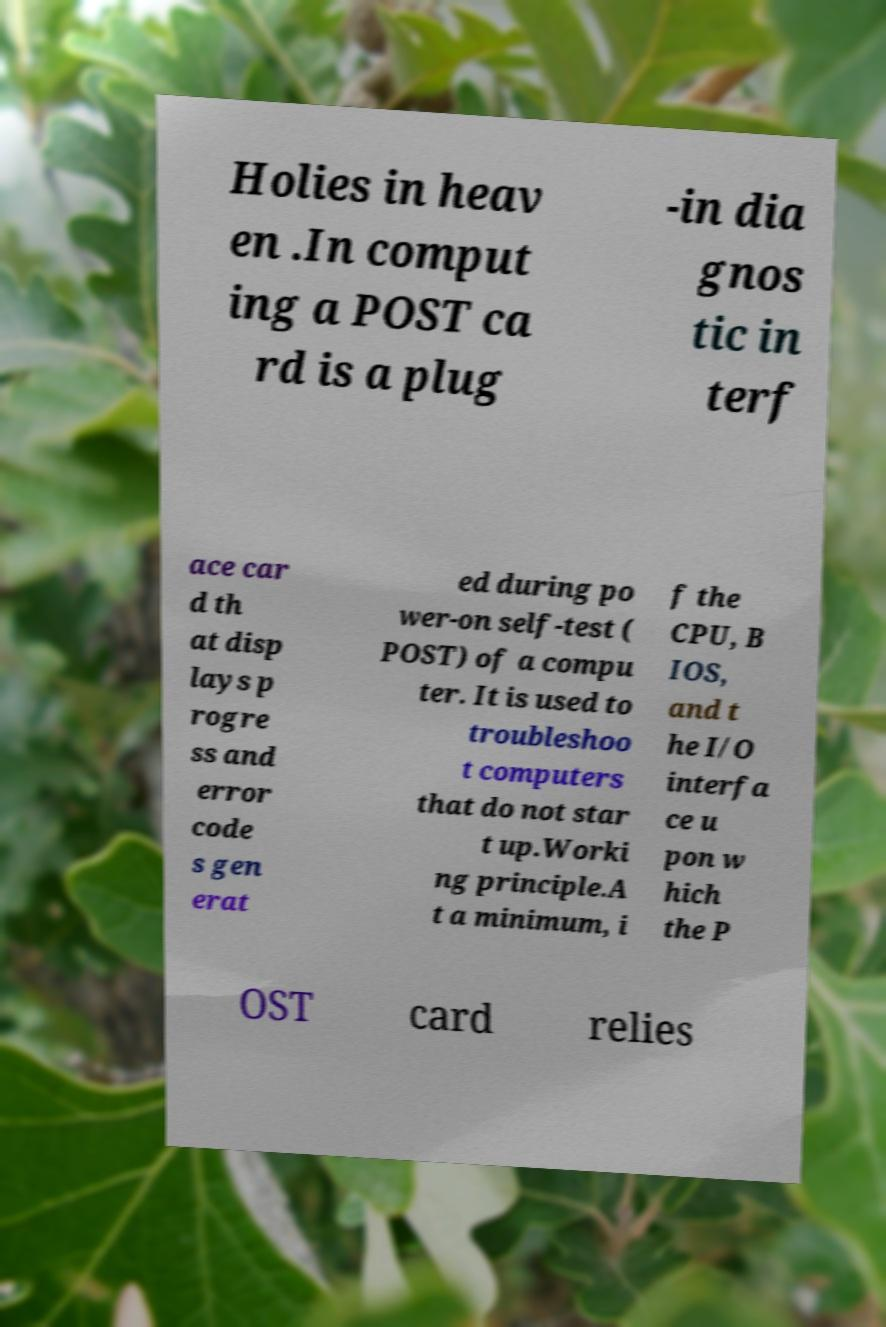Can you accurately transcribe the text from the provided image for me? Holies in heav en .In comput ing a POST ca rd is a plug -in dia gnos tic in terf ace car d th at disp lays p rogre ss and error code s gen erat ed during po wer-on self-test ( POST) of a compu ter. It is used to troubleshoo t computers that do not star t up.Worki ng principle.A t a minimum, i f the CPU, B IOS, and t he I/O interfa ce u pon w hich the P OST card relies 